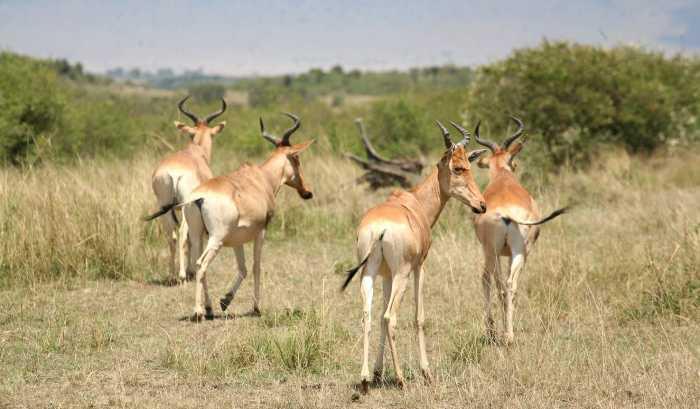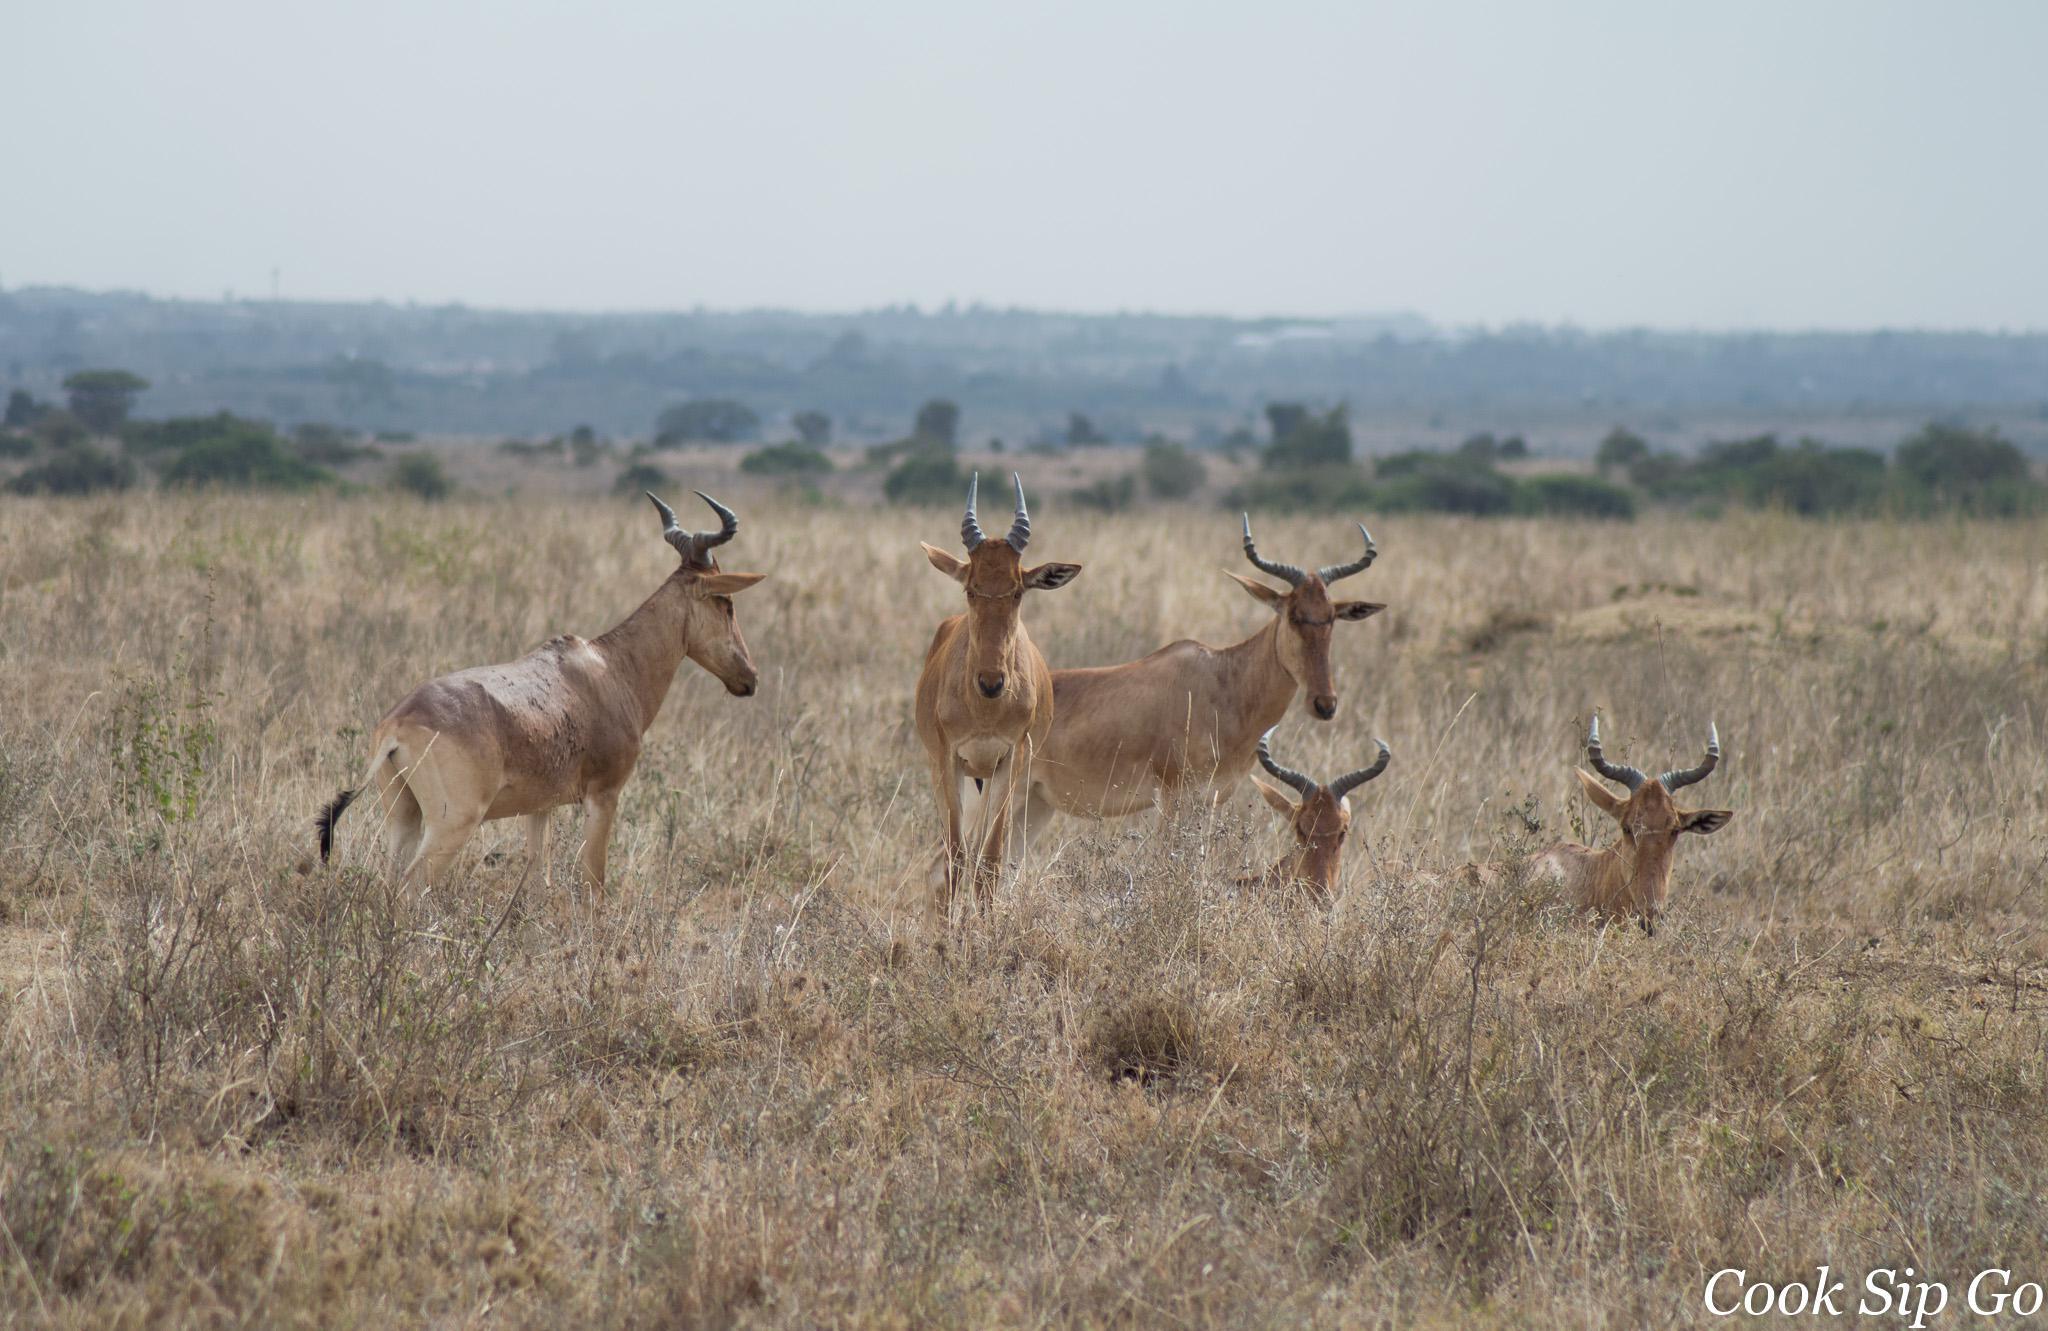The first image is the image on the left, the second image is the image on the right. Evaluate the accuracy of this statement regarding the images: "An image shows exactly five horned animals in reclining and standing poses, with no other mammals present.". Is it true? Answer yes or no. Yes. The first image is the image on the left, the second image is the image on the right. Evaluate the accuracy of this statement regarding the images: "There are five animals in the image on the right.". Is it true? Answer yes or no. Yes. 